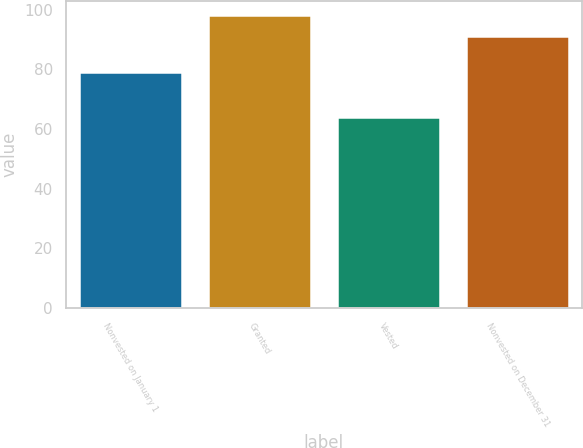Convert chart. <chart><loc_0><loc_0><loc_500><loc_500><bar_chart><fcel>Nonvested on January 1<fcel>Granted<fcel>Vested<fcel>Nonvested on December 31<nl><fcel>79.02<fcel>98.1<fcel>64.01<fcel>91.19<nl></chart> 